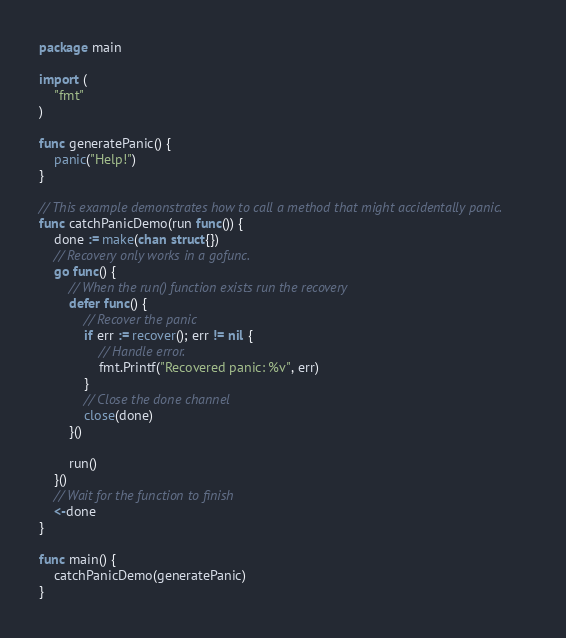<code> <loc_0><loc_0><loc_500><loc_500><_Go_>package main

import (
	"fmt"
)

func generatePanic() {
	panic("Help!")
}

// This example demonstrates how to call a method that might accidentally panic.
func catchPanicDemo(run func()) {
	done := make(chan struct{})
	// Recovery only works in a gofunc.
	go func() {
		// When the run() function exists run the recovery
		defer func() {
			// Recover the panic
			if err := recover(); err != nil {
				// Handle error.
				fmt.Printf("Recovered panic: %v", err)
			}
			// Close the done channel
			close(done)
		}()

		run()
	}()
	// Wait for the function to finish
	<-done
}

func main() {
	catchPanicDemo(generatePanic)
}
</code> 